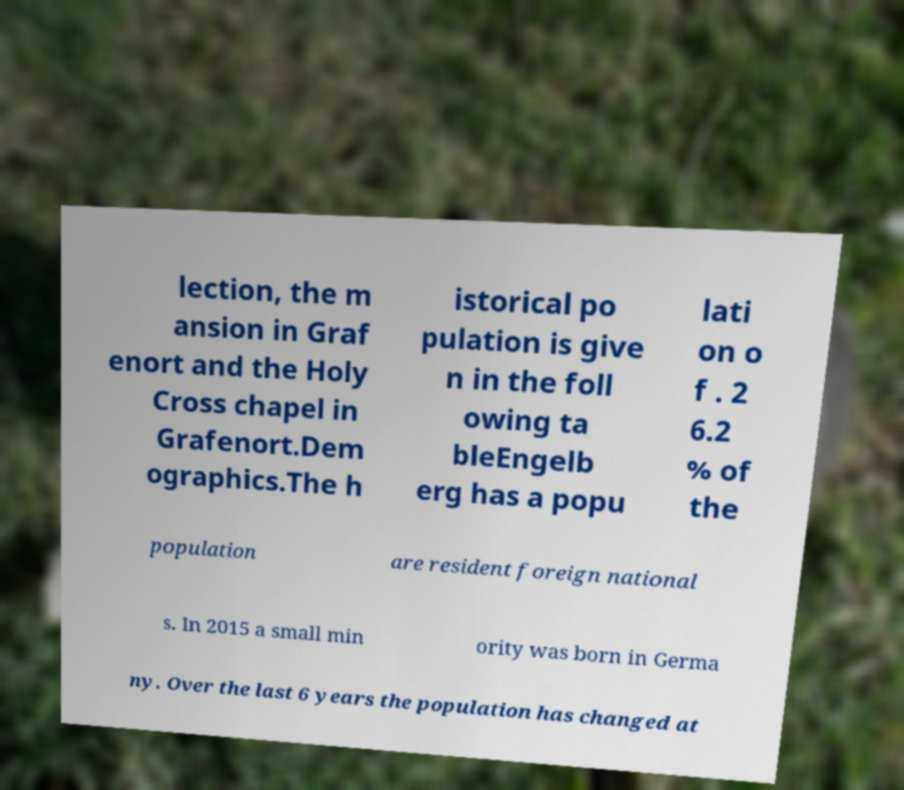I need the written content from this picture converted into text. Can you do that? lection, the m ansion in Graf enort and the Holy Cross chapel in Grafenort.Dem ographics.The h istorical po pulation is give n in the foll owing ta bleEngelb erg has a popu lati on o f . 2 6.2 % of the population are resident foreign national s. In 2015 a small min ority was born in Germa ny. Over the last 6 years the population has changed at 